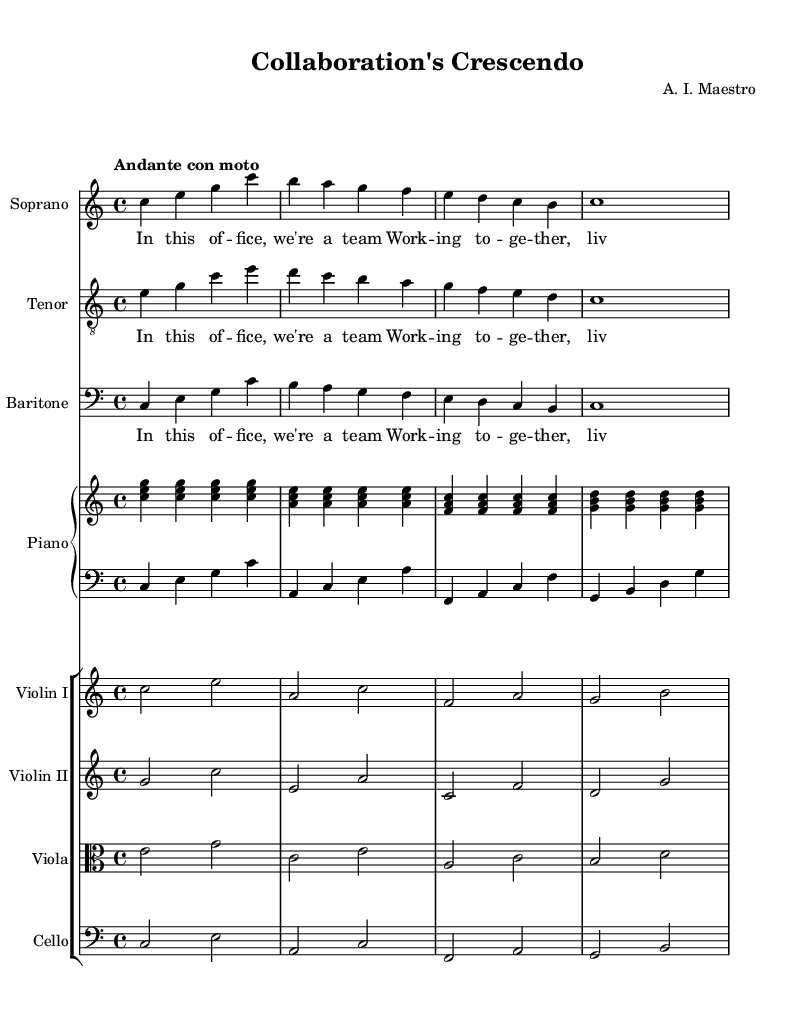What is the key signature of this music? The key signature is indicated at the beginning of the score. It shows no sharps or flats, which identifies it as C major.
Answer: C major What is the time signature of this music? The time signature appears at the start of the score, represented by the 4/4 notation. This indicates that there are four beats per measure and the quarter note gets one beat.
Answer: 4/4 What is the tempo marking of this piece? The tempo marking is found in the score, indicated as "Andante con moto," which provides guidance on the pacing of the performance.
Answer: Andante con moto How many vocal parts are present in this opera piece? The score lists three distinct vocal staves: Soprano, Tenor, and Baritone, indicating the number of vocal parts.
Answer: Three Which instruments are included in the orchestration? By examining the score, one can identify the presence of the Piano, Violin I, Violin II, Viola, and Cello as the orchestral elements.
Answer: Piano, Violins, Viola, Cello What is the lyric theme of the song? The lyrics consistently mention teamwork and collaboration in the workplace, emphasizing a united effort towards a common goal, reflective of workplace dynamics.
Answer: Teamwork What is the structure of the first vocal line? The first vocal line for Soprano follows a simple, repetitive pattern, consisting of four measures with notes and corresponding lyrics that reinforce the theme of teamwork.
Answer: Four measures 